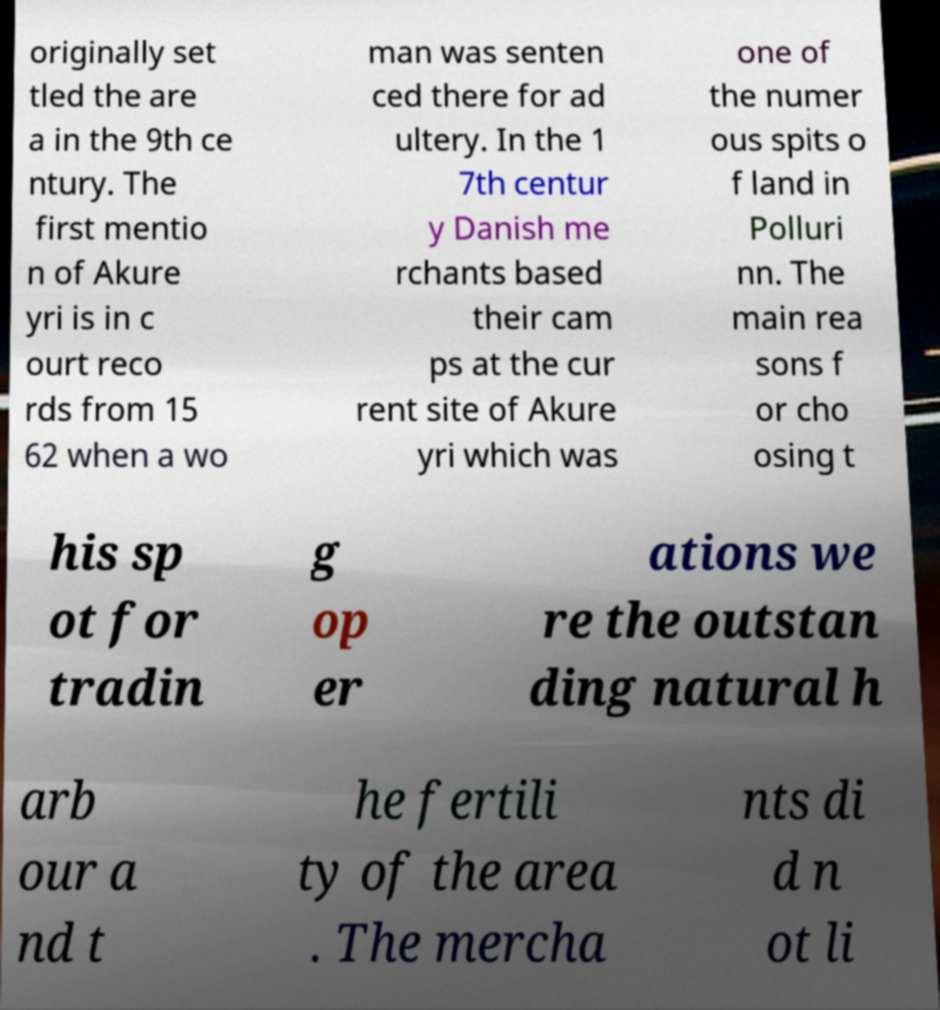Please identify and transcribe the text found in this image. originally set tled the are a in the 9th ce ntury. The first mentio n of Akure yri is in c ourt reco rds from 15 62 when a wo man was senten ced there for ad ultery. In the 1 7th centur y Danish me rchants based their cam ps at the cur rent site of Akure yri which was one of the numer ous spits o f land in Polluri nn. The main rea sons f or cho osing t his sp ot for tradin g op er ations we re the outstan ding natural h arb our a nd t he fertili ty of the area . The mercha nts di d n ot li 